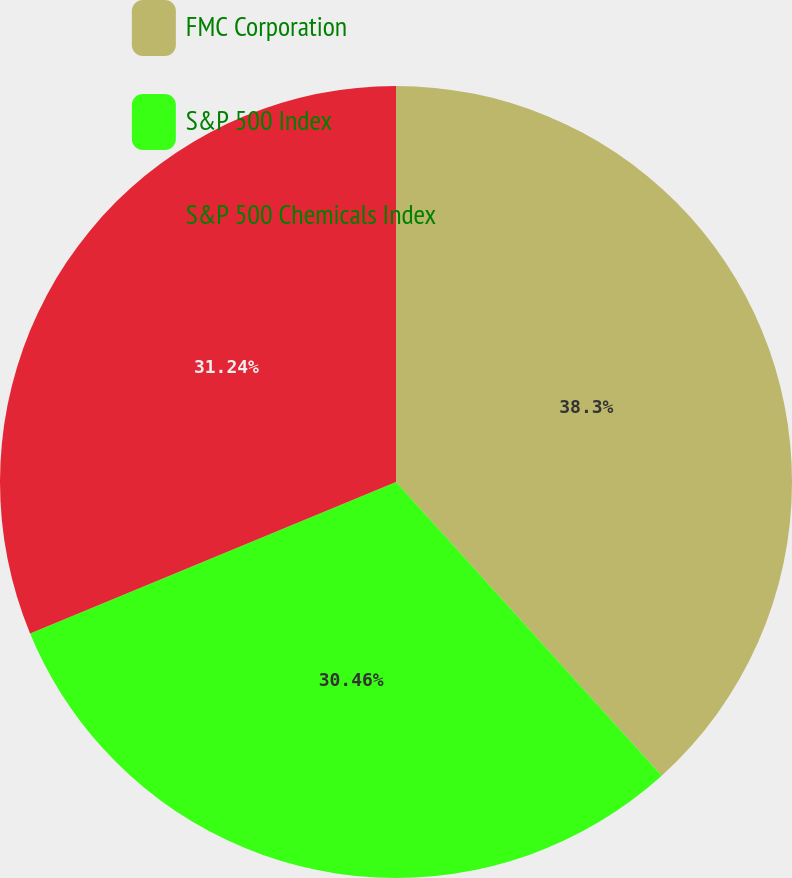Convert chart. <chart><loc_0><loc_0><loc_500><loc_500><pie_chart><fcel>FMC Corporation<fcel>S&P 500 Index<fcel>S&P 500 Chemicals Index<nl><fcel>38.29%<fcel>30.46%<fcel>31.24%<nl></chart> 